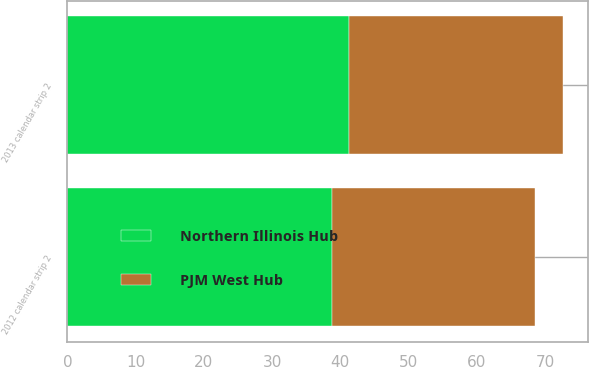<chart> <loc_0><loc_0><loc_500><loc_500><stacked_bar_chart><ecel><fcel>2012 calendar strip 2<fcel>2013 calendar strip 2<nl><fcel>PJM West Hub<fcel>29.75<fcel>31.41<nl><fcel>Northern Illinois Hub<fcel>38.85<fcel>41.26<nl></chart> 